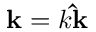Convert formula to latex. <formula><loc_0><loc_0><loc_500><loc_500>k = k \hat { k }</formula> 